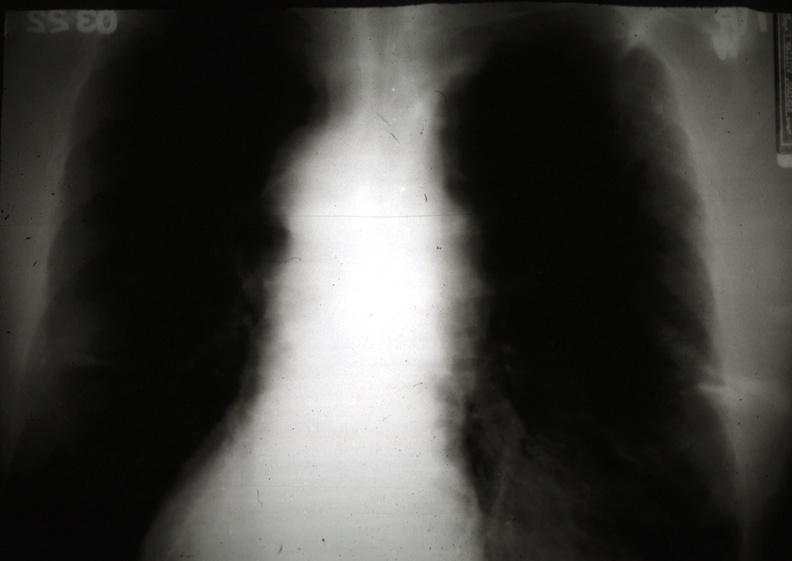what is present?
Answer the question using a single word or phrase. Hematologic 